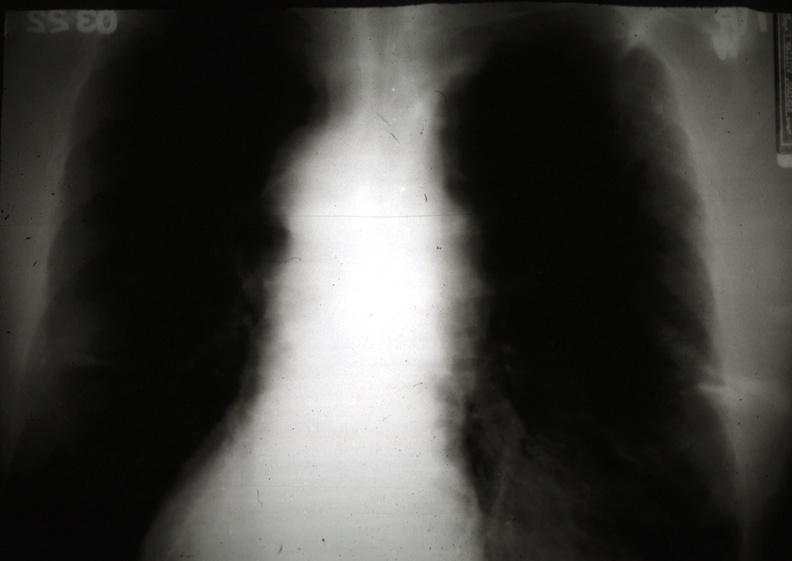what is present?
Answer the question using a single word or phrase. Hematologic 